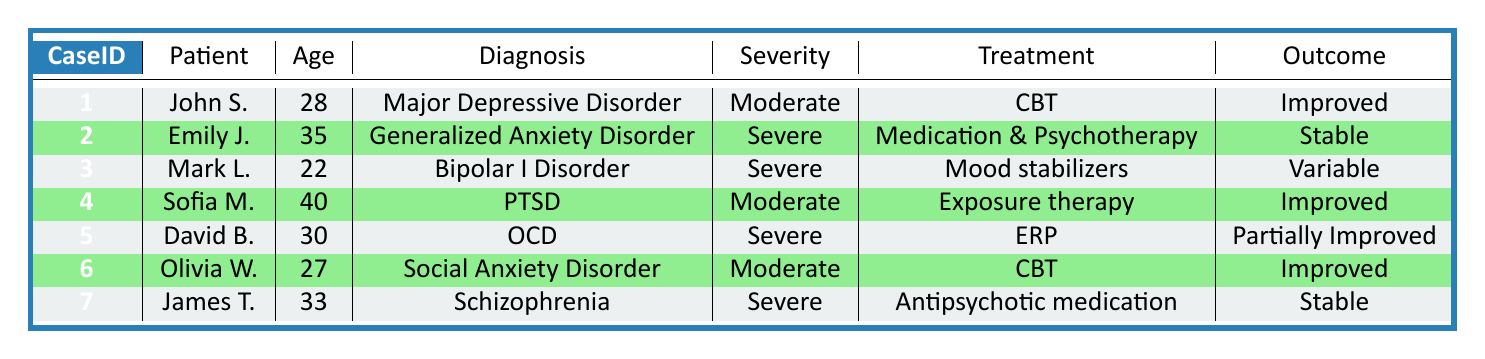What is the age of John Smith? The table shows the information for John Smith in CaseID 1. Under the Age column, it states that he is 28 years old.
Answer: 28 How many patients have a diagnosis of Severe severity? By reviewing the Severity column, we find that there are four cases labeled as Severe (CaseID 2 - Emily Johnson, CaseID 3 - Mark Lee, CaseID 5 - David Brown, and CaseID 7 - James Taylor).
Answer: 4 What treatment did Sofia Martinez receive? For CaseID 4, the treatment column indicates that Sofia Martinez received Exposure therapy.
Answer: Exposure therapy Which patient had a diagnosis of Obsessive-Compulsive Disorder? The table lists each patient along with their respective diagnosis. David Brown in CaseID 5 is noted to have Obsessive-Compulsive Disorder.
Answer: David Brown Is the outcome for James Taylor improved? The outcome column for James Taylor (CaseID 7) specifies that the outcome is Stable, not Improved. Therefore, the statement is false.
Answer: No What is the average age of patients with Moderate severity? There are three patients with Moderate severity: John Smith (28), Sofia Martinez (40), and Olivia Wilson (27). Adding these ages gives a total of 95 years (28 + 40 + 27 = 95). Dividing by 3 gives an average age of 31.67, which can be rounded to 32.
Answer: 32 Which gender has more patients in this table? By counting the number of males (4 cases: John, Mark, David, and James) and females (3 cases: Emily, Sofia, and Olivia), it is clear that there are more males than females.
Answer: Male What is the follow-up period for the patient with Bipolar I Disorder? Looking at CaseID 3 for Mark Lee, the follow-up column specifies a period of 1 year.
Answer: 1 year What outcome corresponds to the treatment of Medication and Psychotherapy? According to the table, the patient Emily Johnson (CaseID 2) who received Medication and Psychotherapy has an outcome labeled as Stable.
Answer: Stable 